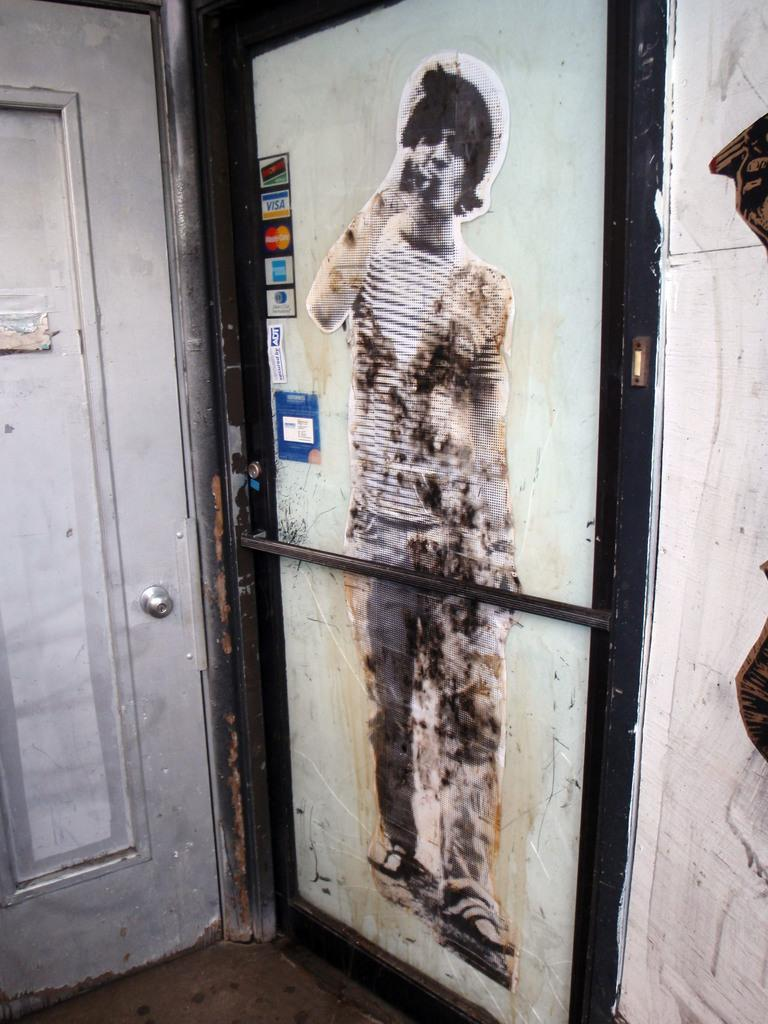What is present on the doors in the image? There are posters on doors in the image. What object can be seen in the image that is typically used for hanging clothes? There is a rod in the image. What part of the door is visible in the image? There is a door handle in the image. What type of structure is visible in the image? There is a wall in the image. Can you see a man climbing a mountain in the image? There is no man climbing a mountain in the image. How many feet are visible in the image? There are no feet visible in the image. 